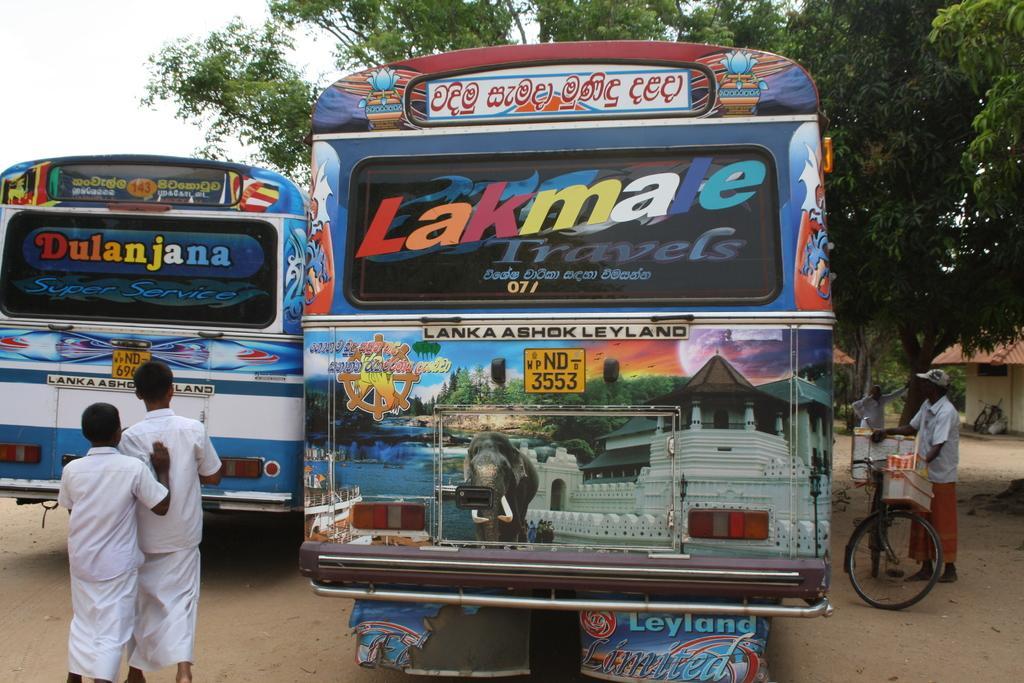Please provide a concise description of this image. This image consists of buses. At the bottom, there is a road. On the left, the two persons wearing white dress. On the right, there is a person standing near the cycle. In the background, there are trees. At the top, there is sky. 